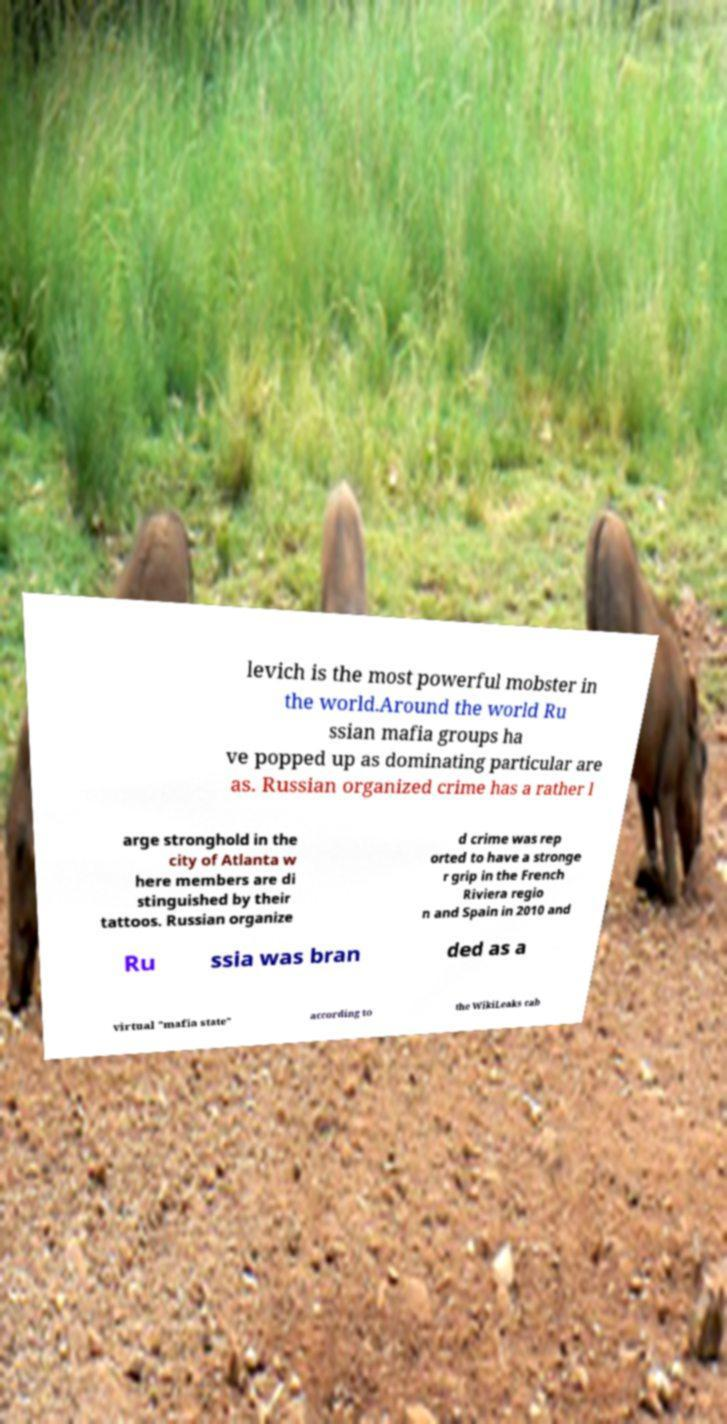Please identify and transcribe the text found in this image. levich is the most powerful mobster in the world.Around the world Ru ssian mafia groups ha ve popped up as dominating particular are as. Russian organized crime has a rather l arge stronghold in the city of Atlanta w here members are di stinguished by their tattoos. Russian organize d crime was rep orted to have a stronge r grip in the French Riviera regio n and Spain in 2010 and Ru ssia was bran ded as a virtual "mafia state" according to the WikiLeaks cab 